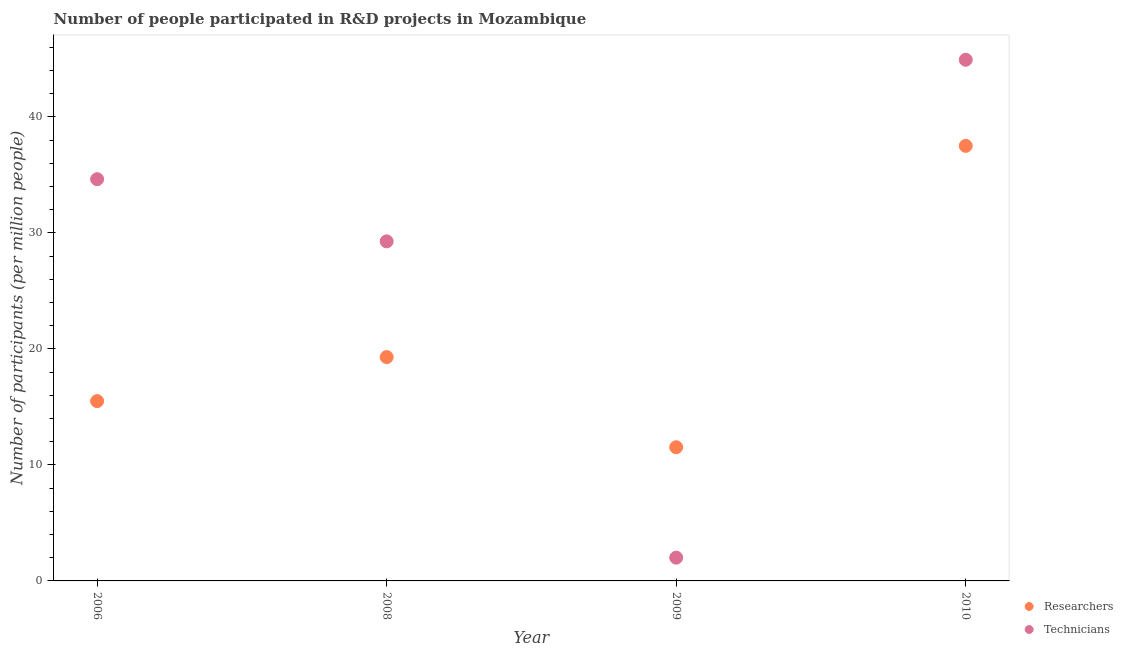How many different coloured dotlines are there?
Give a very brief answer. 2. What is the number of technicians in 2010?
Ensure brevity in your answer.  44.93. Across all years, what is the maximum number of researchers?
Provide a short and direct response. 37.51. Across all years, what is the minimum number of researchers?
Provide a succinct answer. 11.53. In which year was the number of technicians maximum?
Ensure brevity in your answer.  2010. What is the total number of researchers in the graph?
Ensure brevity in your answer.  83.84. What is the difference between the number of technicians in 2006 and that in 2010?
Keep it short and to the point. -10.29. What is the difference between the number of researchers in 2008 and the number of technicians in 2009?
Ensure brevity in your answer.  17.29. What is the average number of researchers per year?
Provide a succinct answer. 20.96. In the year 2008, what is the difference between the number of researchers and number of technicians?
Provide a short and direct response. -9.98. In how many years, is the number of researchers greater than 18?
Provide a succinct answer. 2. What is the ratio of the number of researchers in 2008 to that in 2009?
Provide a short and direct response. 1.67. Is the number of technicians in 2006 less than that in 2008?
Offer a very short reply. No. What is the difference between the highest and the second highest number of researchers?
Offer a very short reply. 18.21. What is the difference between the highest and the lowest number of researchers?
Provide a succinct answer. 25.99. Is the sum of the number of researchers in 2006 and 2010 greater than the maximum number of technicians across all years?
Offer a very short reply. Yes. Is the number of researchers strictly greater than the number of technicians over the years?
Make the answer very short. No. How many dotlines are there?
Make the answer very short. 2. Does the graph contain grids?
Give a very brief answer. No. Where does the legend appear in the graph?
Keep it short and to the point. Bottom right. What is the title of the graph?
Make the answer very short. Number of people participated in R&D projects in Mozambique. What is the label or title of the Y-axis?
Provide a succinct answer. Number of participants (per million people). What is the Number of participants (per million people) of Researchers in 2006?
Provide a succinct answer. 15.5. What is the Number of participants (per million people) of Technicians in 2006?
Your answer should be very brief. 34.64. What is the Number of participants (per million people) in Researchers in 2008?
Offer a terse response. 19.3. What is the Number of participants (per million people) of Technicians in 2008?
Provide a short and direct response. 29.28. What is the Number of participants (per million people) in Researchers in 2009?
Offer a very short reply. 11.53. What is the Number of participants (per million people) in Technicians in 2009?
Provide a succinct answer. 2.01. What is the Number of participants (per million people) of Researchers in 2010?
Offer a very short reply. 37.51. What is the Number of participants (per million people) in Technicians in 2010?
Offer a very short reply. 44.93. Across all years, what is the maximum Number of participants (per million people) of Researchers?
Provide a short and direct response. 37.51. Across all years, what is the maximum Number of participants (per million people) in Technicians?
Offer a very short reply. 44.93. Across all years, what is the minimum Number of participants (per million people) in Researchers?
Your answer should be very brief. 11.53. Across all years, what is the minimum Number of participants (per million people) of Technicians?
Make the answer very short. 2.01. What is the total Number of participants (per million people) of Researchers in the graph?
Provide a succinct answer. 83.84. What is the total Number of participants (per million people) in Technicians in the graph?
Give a very brief answer. 110.86. What is the difference between the Number of participants (per million people) of Researchers in 2006 and that in 2008?
Your response must be concise. -3.8. What is the difference between the Number of participants (per million people) of Technicians in 2006 and that in 2008?
Offer a very short reply. 5.36. What is the difference between the Number of participants (per million people) in Researchers in 2006 and that in 2009?
Keep it short and to the point. 3.98. What is the difference between the Number of participants (per million people) of Technicians in 2006 and that in 2009?
Provide a succinct answer. 32.63. What is the difference between the Number of participants (per million people) of Researchers in 2006 and that in 2010?
Keep it short and to the point. -22.01. What is the difference between the Number of participants (per million people) in Technicians in 2006 and that in 2010?
Keep it short and to the point. -10.29. What is the difference between the Number of participants (per million people) of Researchers in 2008 and that in 2009?
Give a very brief answer. 7.77. What is the difference between the Number of participants (per million people) of Technicians in 2008 and that in 2009?
Provide a succinct answer. 27.27. What is the difference between the Number of participants (per million people) in Researchers in 2008 and that in 2010?
Provide a short and direct response. -18.21. What is the difference between the Number of participants (per million people) of Technicians in 2008 and that in 2010?
Offer a very short reply. -15.66. What is the difference between the Number of participants (per million people) in Researchers in 2009 and that in 2010?
Offer a very short reply. -25.99. What is the difference between the Number of participants (per million people) of Technicians in 2009 and that in 2010?
Provide a succinct answer. -42.93. What is the difference between the Number of participants (per million people) of Researchers in 2006 and the Number of participants (per million people) of Technicians in 2008?
Ensure brevity in your answer.  -13.77. What is the difference between the Number of participants (per million people) in Researchers in 2006 and the Number of participants (per million people) in Technicians in 2009?
Offer a very short reply. 13.5. What is the difference between the Number of participants (per million people) in Researchers in 2006 and the Number of participants (per million people) in Technicians in 2010?
Your answer should be compact. -29.43. What is the difference between the Number of participants (per million people) of Researchers in 2008 and the Number of participants (per million people) of Technicians in 2009?
Give a very brief answer. 17.29. What is the difference between the Number of participants (per million people) of Researchers in 2008 and the Number of participants (per million people) of Technicians in 2010?
Provide a short and direct response. -25.63. What is the difference between the Number of participants (per million people) in Researchers in 2009 and the Number of participants (per million people) in Technicians in 2010?
Offer a terse response. -33.41. What is the average Number of participants (per million people) in Researchers per year?
Give a very brief answer. 20.96. What is the average Number of participants (per million people) of Technicians per year?
Make the answer very short. 27.71. In the year 2006, what is the difference between the Number of participants (per million people) of Researchers and Number of participants (per million people) of Technicians?
Your answer should be very brief. -19.14. In the year 2008, what is the difference between the Number of participants (per million people) of Researchers and Number of participants (per million people) of Technicians?
Ensure brevity in your answer.  -9.98. In the year 2009, what is the difference between the Number of participants (per million people) of Researchers and Number of participants (per million people) of Technicians?
Keep it short and to the point. 9.52. In the year 2010, what is the difference between the Number of participants (per million people) of Researchers and Number of participants (per million people) of Technicians?
Keep it short and to the point. -7.42. What is the ratio of the Number of participants (per million people) of Researchers in 2006 to that in 2008?
Provide a succinct answer. 0.8. What is the ratio of the Number of participants (per million people) in Technicians in 2006 to that in 2008?
Your response must be concise. 1.18. What is the ratio of the Number of participants (per million people) of Researchers in 2006 to that in 2009?
Your answer should be compact. 1.34. What is the ratio of the Number of participants (per million people) of Technicians in 2006 to that in 2009?
Provide a succinct answer. 17.27. What is the ratio of the Number of participants (per million people) of Researchers in 2006 to that in 2010?
Make the answer very short. 0.41. What is the ratio of the Number of participants (per million people) in Technicians in 2006 to that in 2010?
Your answer should be compact. 0.77. What is the ratio of the Number of participants (per million people) of Researchers in 2008 to that in 2009?
Your response must be concise. 1.67. What is the ratio of the Number of participants (per million people) in Technicians in 2008 to that in 2009?
Offer a very short reply. 14.59. What is the ratio of the Number of participants (per million people) in Researchers in 2008 to that in 2010?
Offer a very short reply. 0.51. What is the ratio of the Number of participants (per million people) of Technicians in 2008 to that in 2010?
Offer a terse response. 0.65. What is the ratio of the Number of participants (per million people) of Researchers in 2009 to that in 2010?
Keep it short and to the point. 0.31. What is the ratio of the Number of participants (per million people) in Technicians in 2009 to that in 2010?
Your answer should be compact. 0.04. What is the difference between the highest and the second highest Number of participants (per million people) in Researchers?
Your response must be concise. 18.21. What is the difference between the highest and the second highest Number of participants (per million people) in Technicians?
Provide a short and direct response. 10.29. What is the difference between the highest and the lowest Number of participants (per million people) in Researchers?
Give a very brief answer. 25.99. What is the difference between the highest and the lowest Number of participants (per million people) of Technicians?
Keep it short and to the point. 42.93. 